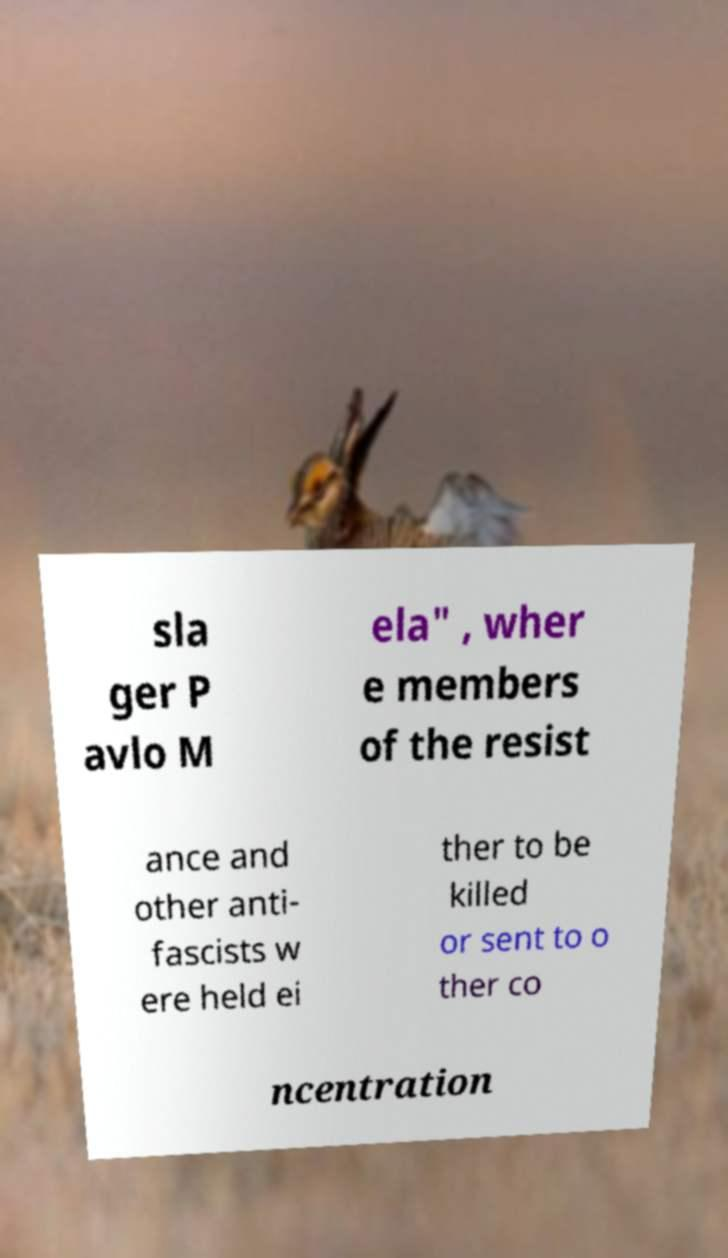Could you extract and type out the text from this image? sla ger P avlo M ela" , wher e members of the resist ance and other anti- fascists w ere held ei ther to be killed or sent to o ther co ncentration 